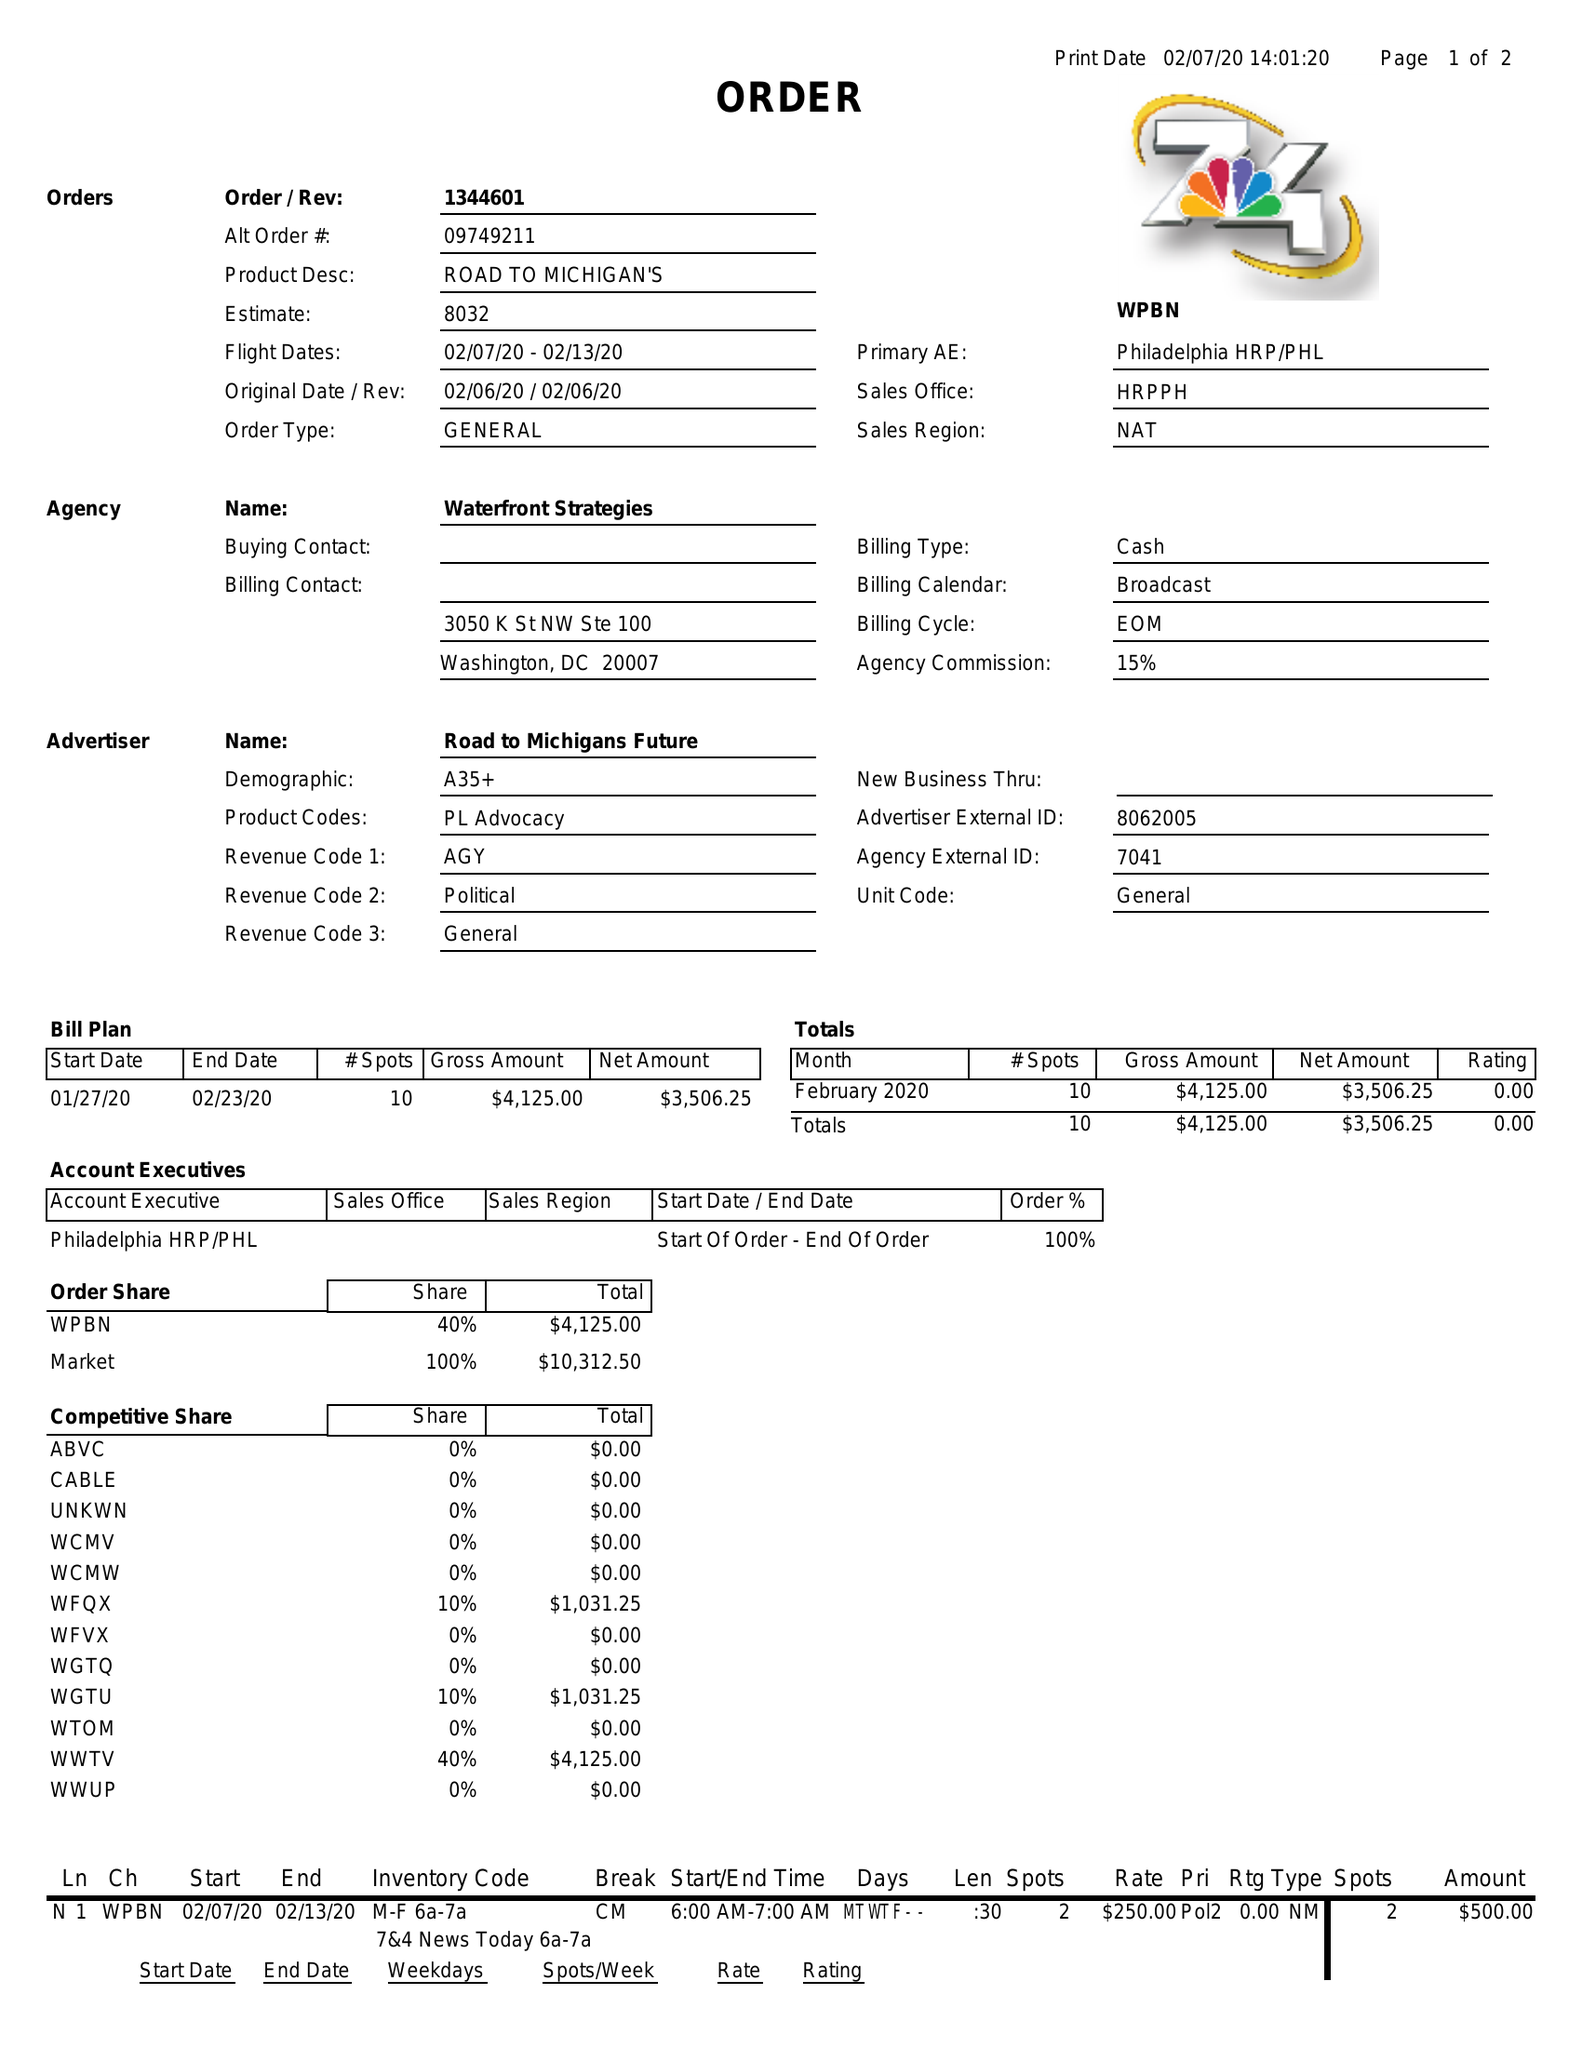What is the value for the flight_from?
Answer the question using a single word or phrase. 02/07/20 